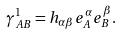<formula> <loc_0><loc_0><loc_500><loc_500>\gamma ^ { 1 } _ { A B } = h _ { \alpha \beta } e ^ { \alpha } _ { A } e ^ { \beta } _ { B } .</formula> 